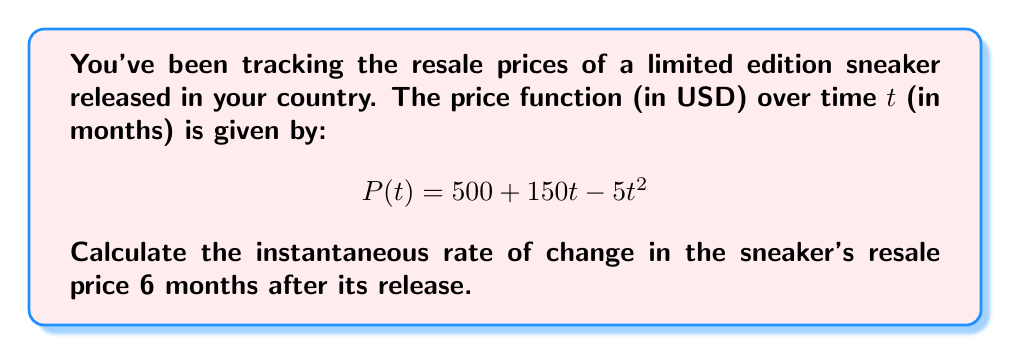Give your solution to this math problem. To find the instantaneous rate of change at a specific point, we need to calculate the derivative of the price function and evaluate it at the given time.

1. First, let's find the derivative of P(t):
   $$P(t) = 500 + 150t - 5t^2$$
   $$P'(t) = 150 - 10t$$

   This derivative represents the rate of change of the price at any given time t.

2. Now, we need to evaluate P'(t) at t = 6 months:
   $$P'(6) = 150 - 10(6)$$
   $$P'(6) = 150 - 60$$
   $$P'(6) = 90$$

3. Interpret the result:
   The positive value indicates that the price is still increasing at t = 6 months, but at a slower rate than initially.
Answer: The instantaneous rate of change in the sneaker's resale price 6 months after its release is $90 per month. 